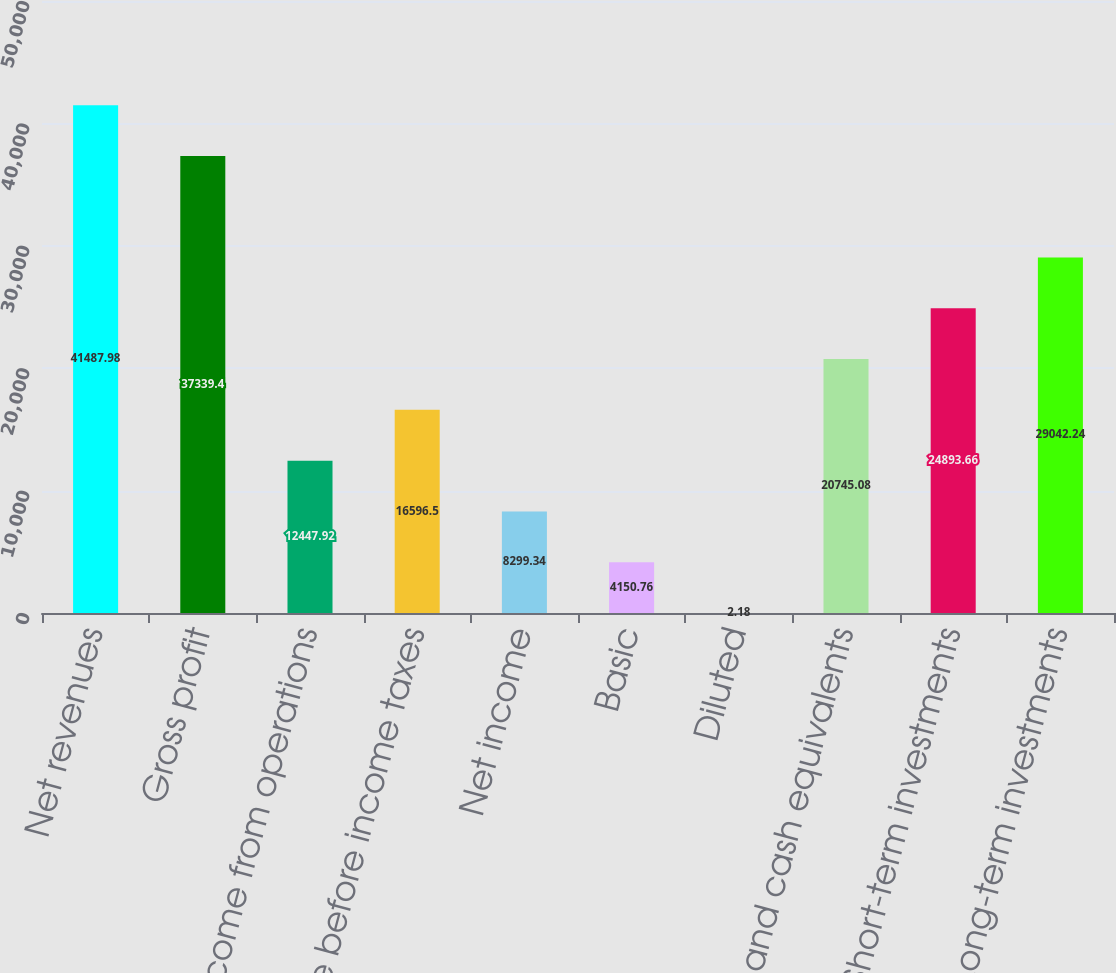<chart> <loc_0><loc_0><loc_500><loc_500><bar_chart><fcel>Net revenues<fcel>Gross profit<fcel>Income from operations<fcel>Income before income taxes<fcel>Net income<fcel>Basic<fcel>Diluted<fcel>Cash and cash equivalents<fcel>Short-term investments<fcel>Long-term investments<nl><fcel>41488<fcel>37339.4<fcel>12447.9<fcel>16596.5<fcel>8299.34<fcel>4150.76<fcel>2.18<fcel>20745.1<fcel>24893.7<fcel>29042.2<nl></chart> 